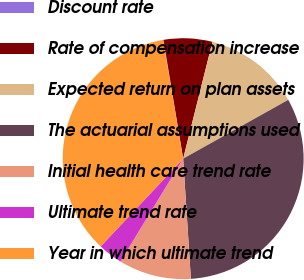Convert chart to OTSL. <chart><loc_0><loc_0><loc_500><loc_500><pie_chart><fcel>Discount rate<fcel>Rate of compensation increase<fcel>Expected return on plan assets<fcel>The actuarial assumptions used<fcel>Initial health care trend rate<fcel>Ultimate trend rate<fcel>Year in which ultimate trend<nl><fcel>0.06%<fcel>6.52%<fcel>12.97%<fcel>32.1%<fcel>9.74%<fcel>3.29%<fcel>35.32%<nl></chart> 